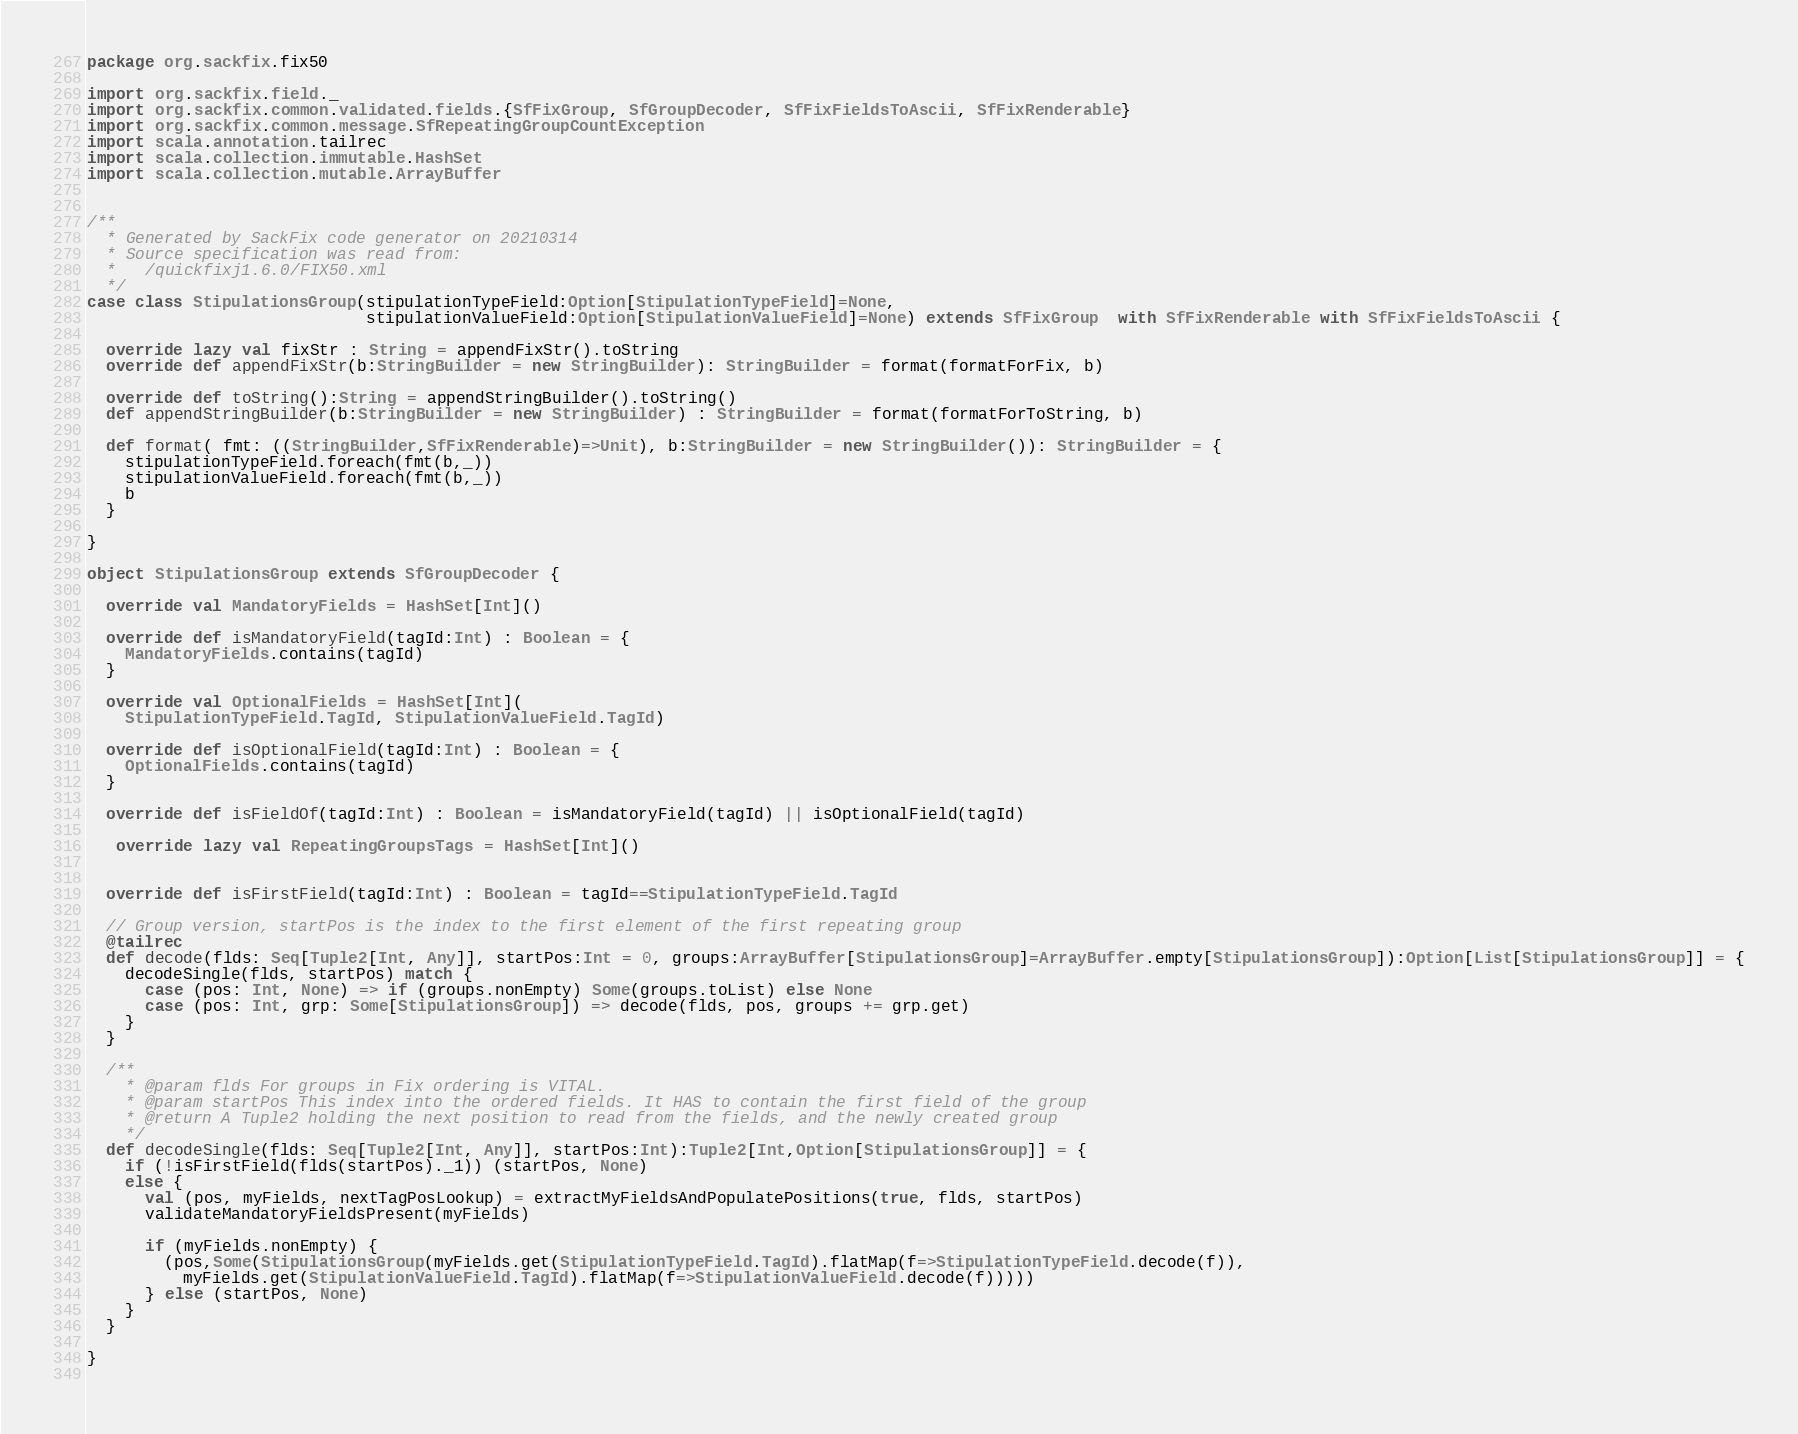<code> <loc_0><loc_0><loc_500><loc_500><_Scala_>package org.sackfix.fix50

import org.sackfix.field._
import org.sackfix.common.validated.fields.{SfFixGroup, SfGroupDecoder, SfFixFieldsToAscii, SfFixRenderable}
import org.sackfix.common.message.SfRepeatingGroupCountException
import scala.annotation.tailrec
import scala.collection.immutable.HashSet
import scala.collection.mutable.ArrayBuffer


/**
  * Generated by SackFix code generator on 20210314
  * Source specification was read from:
  *   /quickfixj1.6.0/FIX50.xml
  */
case class StipulationsGroup(stipulationTypeField:Option[StipulationTypeField]=None,
                             stipulationValueField:Option[StipulationValueField]=None) extends SfFixGroup  with SfFixRenderable with SfFixFieldsToAscii {

  override lazy val fixStr : String = appendFixStr().toString
  override def appendFixStr(b:StringBuilder = new StringBuilder): StringBuilder = format(formatForFix, b)

  override def toString():String = appendStringBuilder().toString()
  def appendStringBuilder(b:StringBuilder = new StringBuilder) : StringBuilder = format(formatForToString, b)

  def format( fmt: ((StringBuilder,SfFixRenderable)=>Unit), b:StringBuilder = new StringBuilder()): StringBuilder = {
    stipulationTypeField.foreach(fmt(b,_))
    stipulationValueField.foreach(fmt(b,_))
    b
  }

}
     
object StipulationsGroup extends SfGroupDecoder {

  override val MandatoryFields = HashSet[Int]()

  override def isMandatoryField(tagId:Int) : Boolean = {
    MandatoryFields.contains(tagId) 
  }

  override val OptionalFields = HashSet[Int](
    StipulationTypeField.TagId, StipulationValueField.TagId)

  override def isOptionalField(tagId:Int) : Boolean = {
    OptionalFields.contains(tagId) 
  }

  override def isFieldOf(tagId:Int) : Boolean = isMandatoryField(tagId) || isOptionalField(tagId) 

   override lazy val RepeatingGroupsTags = HashSet[Int]()
  
      
  override def isFirstField(tagId:Int) : Boolean = tagId==StipulationTypeField.TagId 

  // Group version, startPos is the index to the first element of the first repeating group
  @tailrec
  def decode(flds: Seq[Tuple2[Int, Any]], startPos:Int = 0, groups:ArrayBuffer[StipulationsGroup]=ArrayBuffer.empty[StipulationsGroup]):Option[List[StipulationsGroup]] = {
    decodeSingle(flds, startPos) match {
      case (pos: Int, None) => if (groups.nonEmpty) Some(groups.toList) else None
      case (pos: Int, grp: Some[StipulationsGroup]) => decode(flds, pos, groups += grp.get)
    }
  }

  /**
    * @param flds For groups in Fix ordering is VITAL.
    * @param startPos This index into the ordered fields. It HAS to contain the first field of the group
    * @return A Tuple2 holding the next position to read from the fields, and the newly created group
    */
  def decodeSingle(flds: Seq[Tuple2[Int, Any]], startPos:Int):Tuple2[Int,Option[StipulationsGroup]] = {
    if (!isFirstField(flds(startPos)._1)) (startPos, None)
    else {
      val (pos, myFields, nextTagPosLookup) = extractMyFieldsAndPopulatePositions(true, flds, startPos)
      validateMandatoryFieldsPresent(myFields)

      if (myFields.nonEmpty) {
        (pos,Some(StipulationsGroup(myFields.get(StipulationTypeField.TagId).flatMap(f=>StipulationTypeField.decode(f)),
          myFields.get(StipulationValueField.TagId).flatMap(f=>StipulationValueField.decode(f)))))
      } else (startPos, None)
    }
  }
    
}
     </code> 